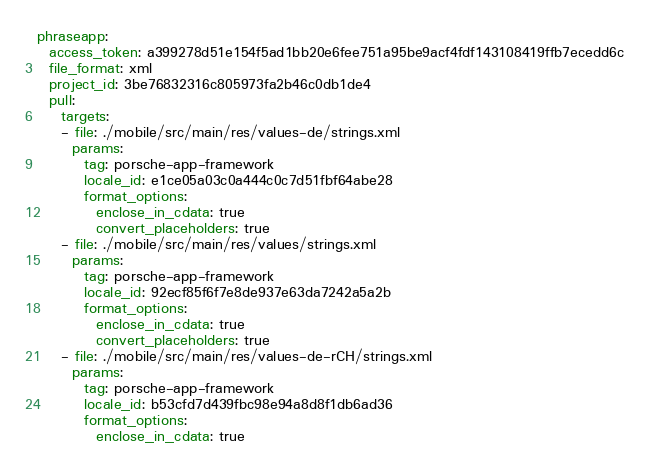<code> <loc_0><loc_0><loc_500><loc_500><_YAML_>phraseapp:
  access_token: a399278d51e154f5ad1bb20e6fee751a95be9acf4fdf143108419ffb7ecedd6c
  file_format: xml
  project_id: 3be76832316c805973fa2b46c0db1de4
  pull:
    targets:
    - file: ./mobile/src/main/res/values-de/strings.xml
      params:
        tag: porsche-app-framework
        locale_id: e1ce05a03c0a444c0c7d51fbf64abe28
        format_options:
          enclose_in_cdata: true
          convert_placeholders: true
    - file: ./mobile/src/main/res/values/strings.xml
      params:
        tag: porsche-app-framework
        locale_id: 92ecf85f6f7e8de937e63da7242a5a2b
        format_options:
          enclose_in_cdata: true
          convert_placeholders: true
    - file: ./mobile/src/main/res/values-de-rCH/strings.xml
      params:
        tag: porsche-app-framework
        locale_id: b53cfd7d439fbc98e94a8d8f1db6ad36
        format_options:
          enclose_in_cdata: true</code> 